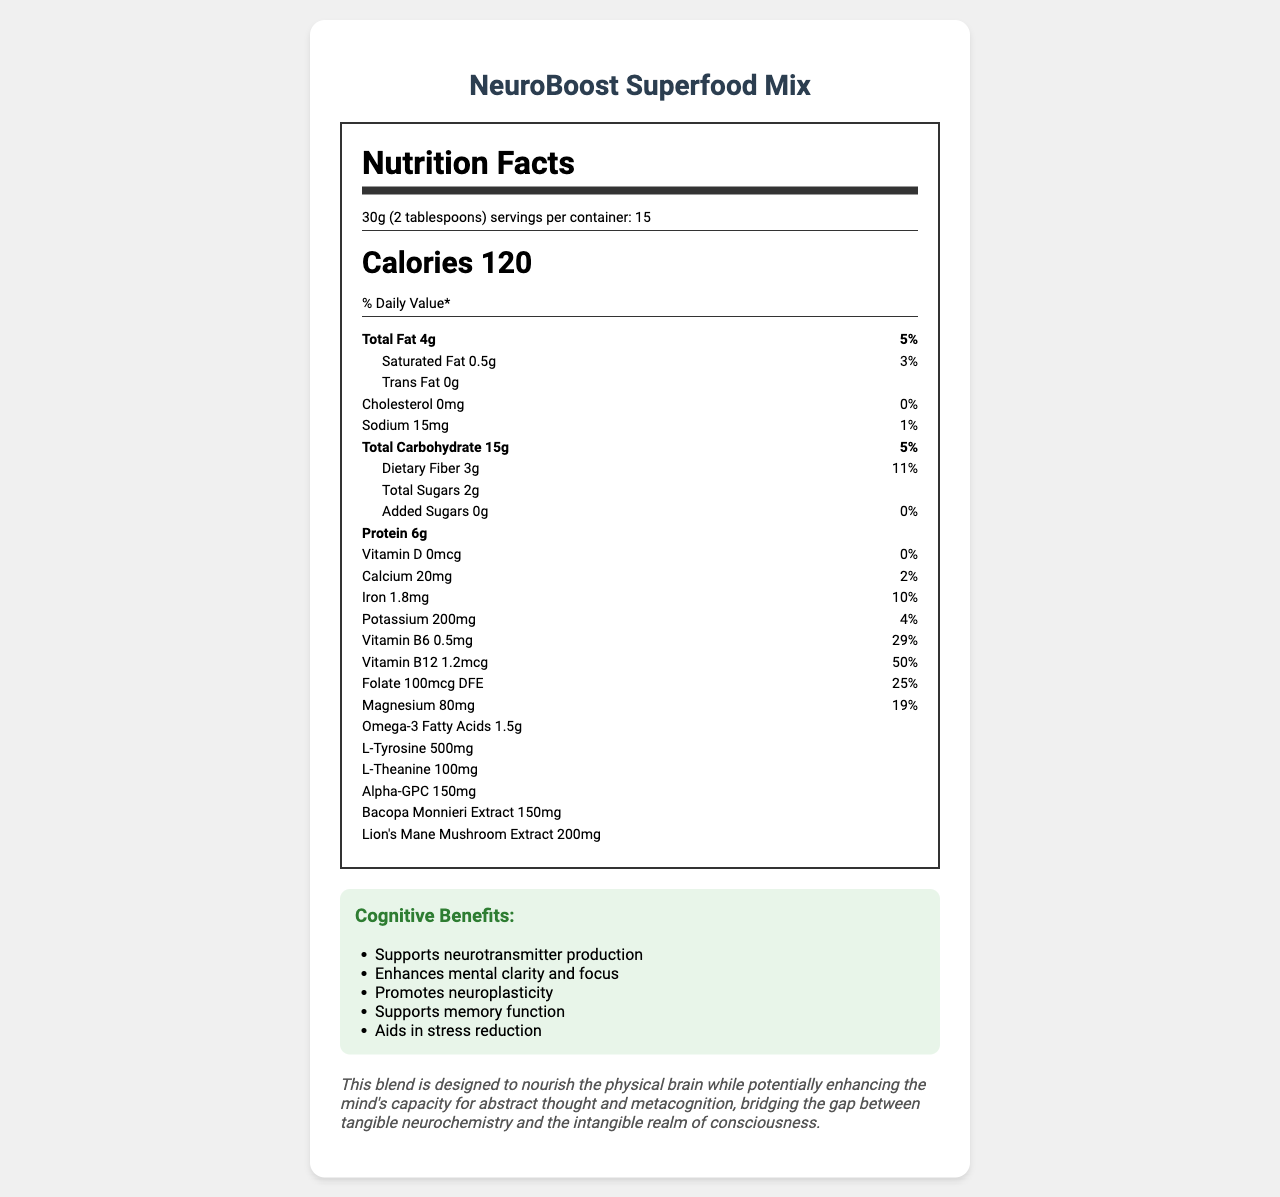what is the serving size of the NeuroBoost Superfood Mix? The serving size is explicitly mentioned at the top of the Nutrition Facts label.
Answer: 30g (2 tablespoons) how many calories are in a single serving? The document states the calorie content directly below the serving size.
Answer: 120 how much protein is in one serving? The protein content is listed near the middle of the Nutrition Facts section.
Answer: 6g what percentage of daily vitamin B12 does one serving contain? The percent daily value for vitamin B12 is provided in the vitamin section of the label.
Answer: 50% how much L-Tyrosine is included in one serving? L-Tyrosine content is listed in the Nutrition Facts section.
Answer: 500mg what are the cognitive benefits mentioned for the NeuroBoost Superfood Mix? The cognitive benefits are explicitly listed in a section at the bottom of the document.
Answer: Supports neurotransmitter production, Enhances mental clarity and focus, Promotes neuroplasticity, Supports memory function, Aids in stress reduction how many grams of total fat does one serving contain? The total fat content is listed towards the top of the Nutrition Facts section.
Answer: 4g Does the NeuroBoost Superfood Mix contain any added sugars? The label specifies 0g of added sugars.
Answer: No how many milligrams of sodium are in each serving? The sodium content is given in the Nutrition Facts section.
Answer: 15mg what is the primary purpose of Alpha-GPC in this mix? The document lists Alpha-GPC among the ingredients but does not provide a specific purpose for its inclusion.
Answer: Cannot be determined which nutrient has the highest percent daily value in one serving? A. Vitamin B6 B. Magnesium C. Folate D. Vitamin B12 Vitamin B12 has a percent daily value of 50%, which is the highest among the listed nutrients.
Answer: D. Vitamin B12 how many servings are in one container? A. 10 B. 12 C. 15 D. 20 The document specifies that there are 15 servings per container.
Answer: C. 15 is there any cholesterol in the NeuroBoost Superfood Mix? The label states that the cholesterol content is 0mg.
Answer: No describe the primary focus of the NeuroBoost Superfood Mix as stated in the metaphysical note. The metaphysical note is clearly outlined at the bottom of the document, explaining the dual focus on physical brain nourishment and enhanced mental capabilities.
Answer: The blend is designed to nourish the physical brain while potentially enhancing the mind's capacity for abstract thought and metacognition, bridging the gap between tangible neurochemistry and the intangible realm of consciousness. is the NeuroBoost Superfood Mix suitable for individuals with nut allergies? The allergen info states that the mix contains tree nuts (pumpkin seeds) and is manufactured in a facility that processes other allergens.
Answer: No 